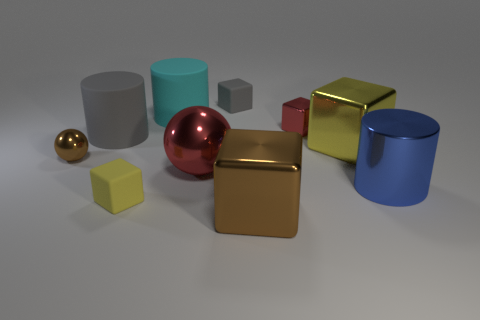What number of other things are there of the same color as the metal cylinder? In the image, there are no other objects with the exact same color as the metal cylinder. Each object displays a distinct hue, differentiating it from the others. 